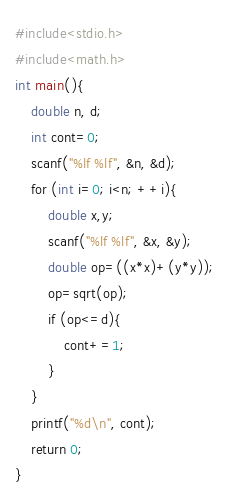<code> <loc_0><loc_0><loc_500><loc_500><_C_>#include<stdio.h>
#include<math.h>
int main(){
    double n, d;
    int cont=0;
    scanf("%lf %lf", &n, &d);
    for (int i=0; i<n; ++i){
        double x,y;
        scanf("%lf %lf", &x, &y);
        double op=((x*x)+(y*y));
        op=sqrt(op);
        if (op<=d){
            cont+=1;
        }
    }
    printf("%d\n", cont);
    return 0;
}
</code> 